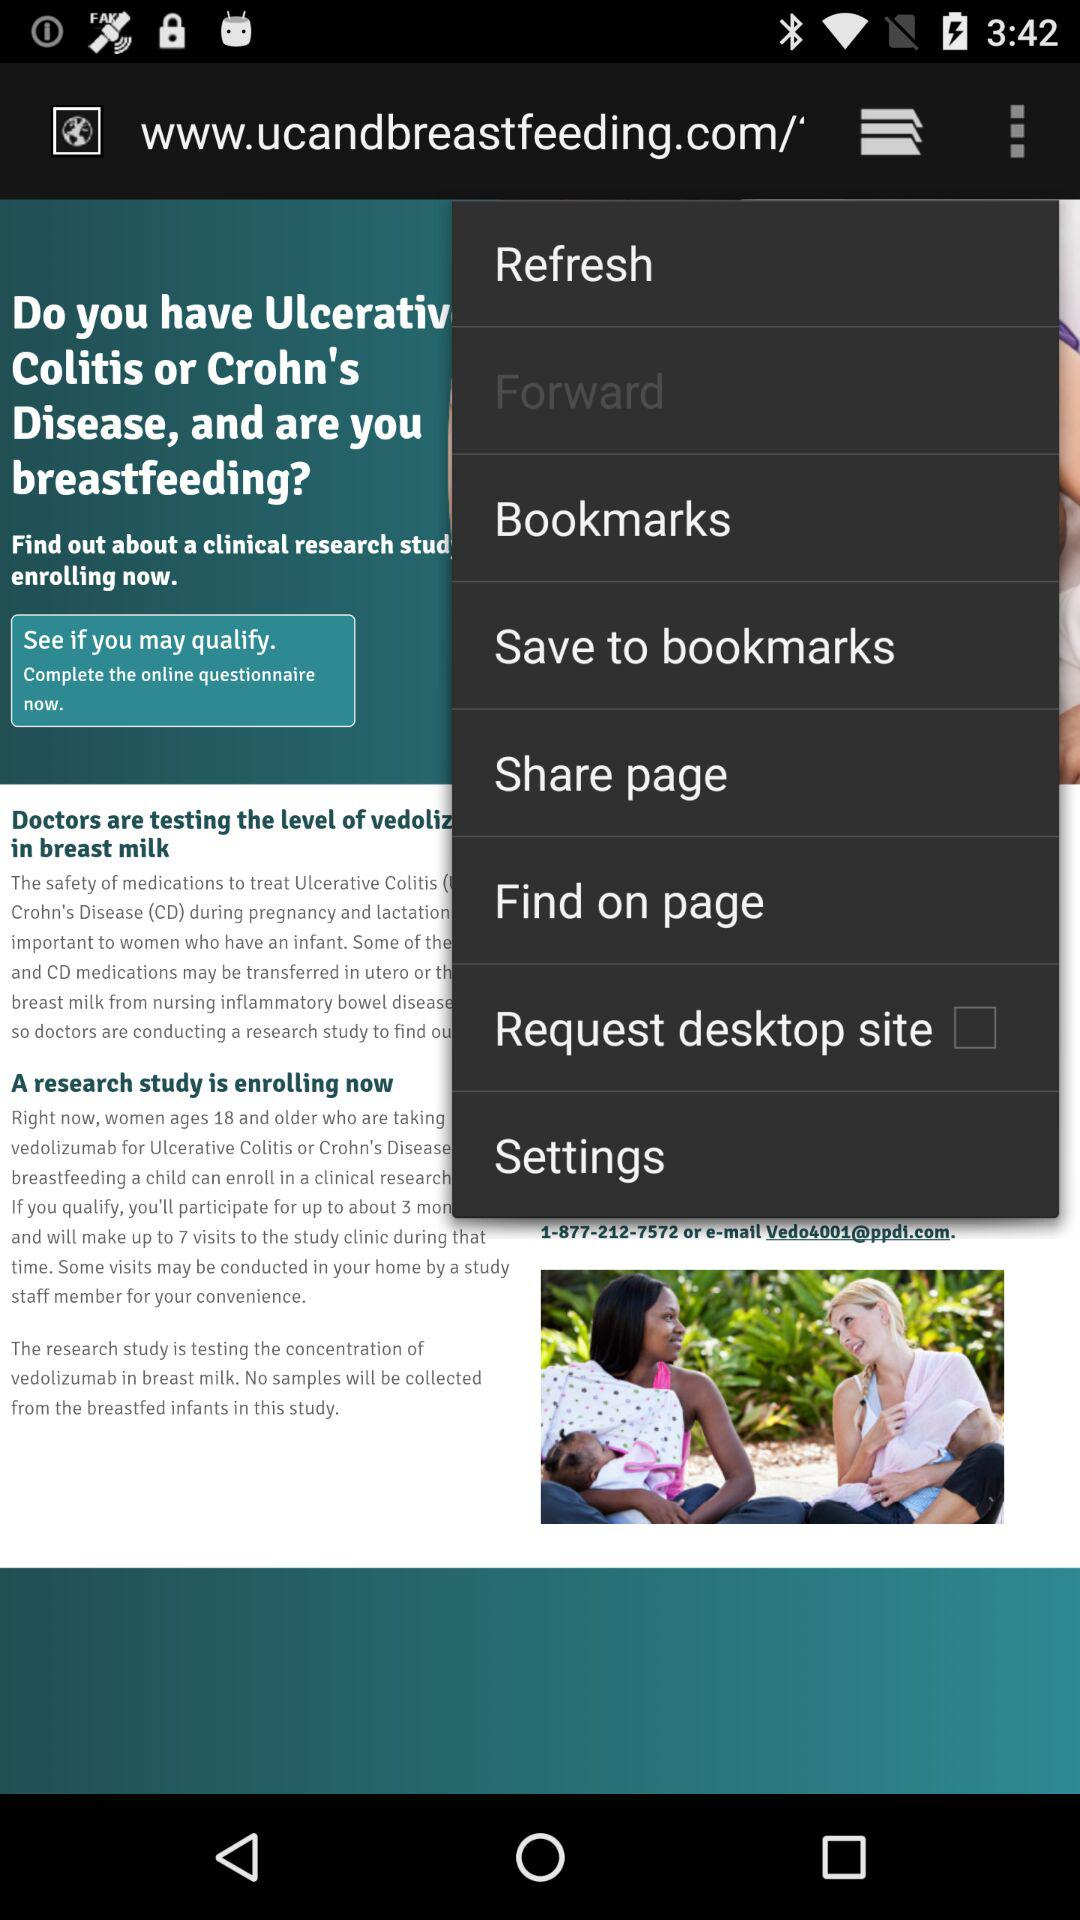What is the status of "Request desktop site"? The status is "off". 